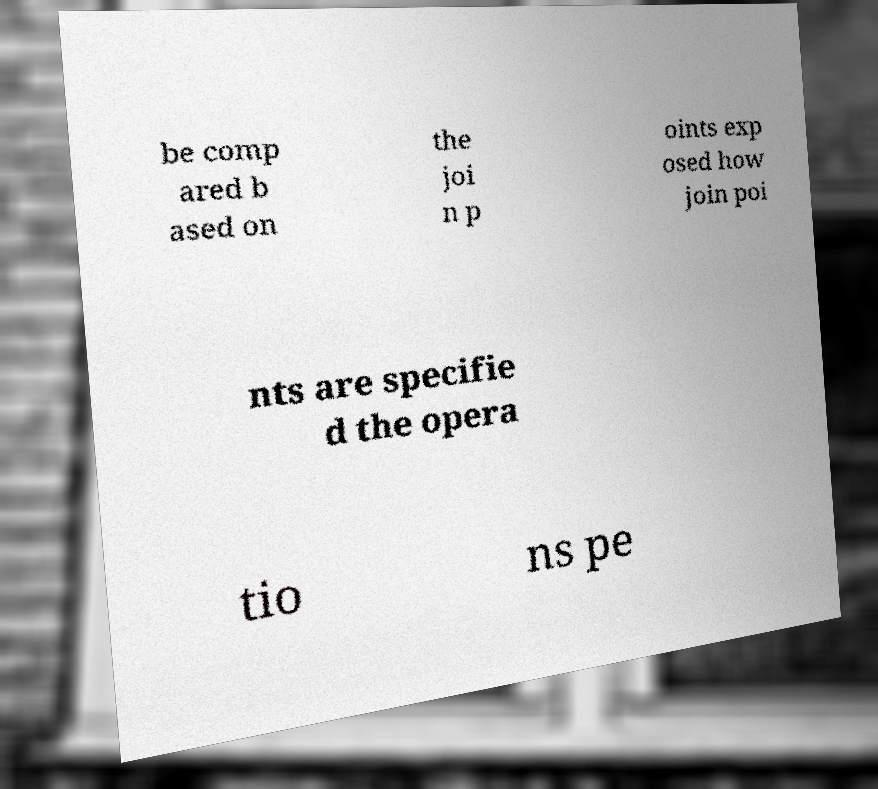For documentation purposes, I need the text within this image transcribed. Could you provide that? be comp ared b ased on the joi n p oints exp osed how join poi nts are specifie d the opera tio ns pe 